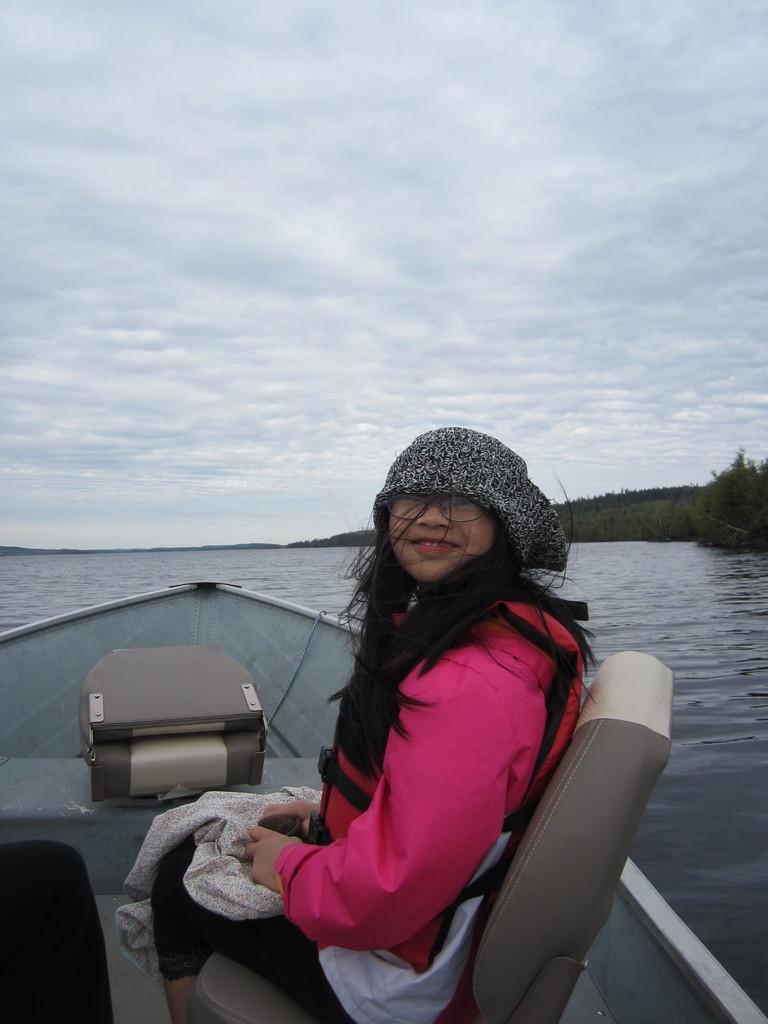How would you summarize this image in a sentence or two? In this image we can see a boat on the water and a person sitting on the chair in the boat and there is an object near the person, there are few trees and the sky with clouds in the background. 